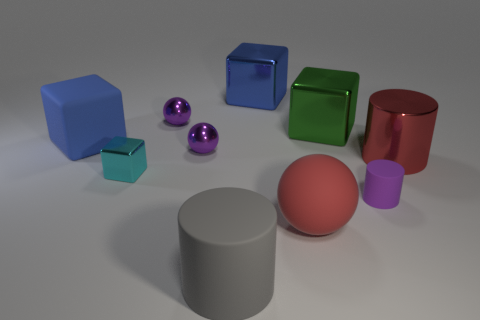Subtract all cylinders. How many objects are left? 7 Add 6 large blue objects. How many large blue objects are left? 8 Add 4 red rubber balls. How many red rubber balls exist? 5 Subtract 1 green cubes. How many objects are left? 9 Subtract all cyan matte things. Subtract all green objects. How many objects are left? 9 